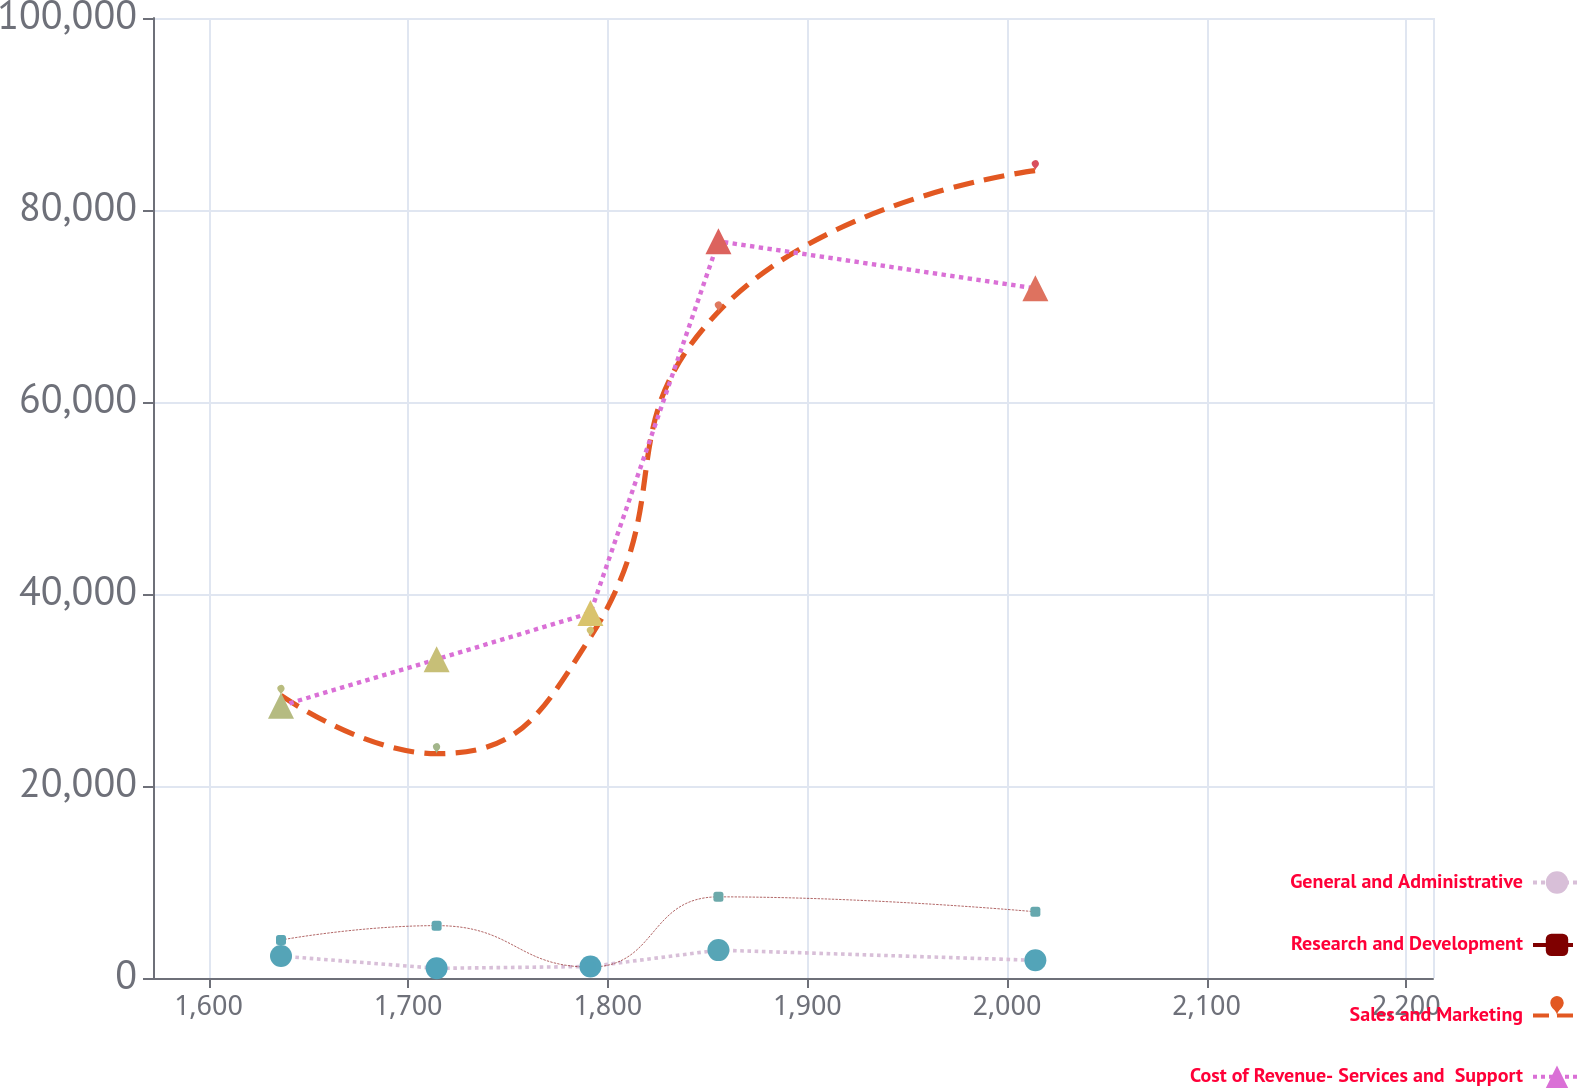Convert chart. <chart><loc_0><loc_0><loc_500><loc_500><line_chart><ecel><fcel>General and Administrative<fcel>Research and Development<fcel>Sales and Marketing<fcel>Cost of Revenue- Services and  Support<nl><fcel>1636.3<fcel>2284.17<fcel>3957.96<fcel>29438.9<fcel>28354.2<nl><fcel>1714.26<fcel>1006.73<fcel>5454.92<fcel>23364.6<fcel>33192.4<nl><fcel>1791.31<fcel>1196.5<fcel>1141.58<fcel>35513.2<fcel>38030.5<nl><fcel>1855.43<fcel>2904.42<fcel>8452.47<fcel>69399.1<fcel>76735.7<nl><fcel>2014.21<fcel>1843.54<fcel>6898.16<fcel>84107.4<fcel>71836.1<nl><fcel>2277.53<fcel>1653.77<fcel>1872.67<fcel>43258.3<fcel>59462.1<nl></chart> 